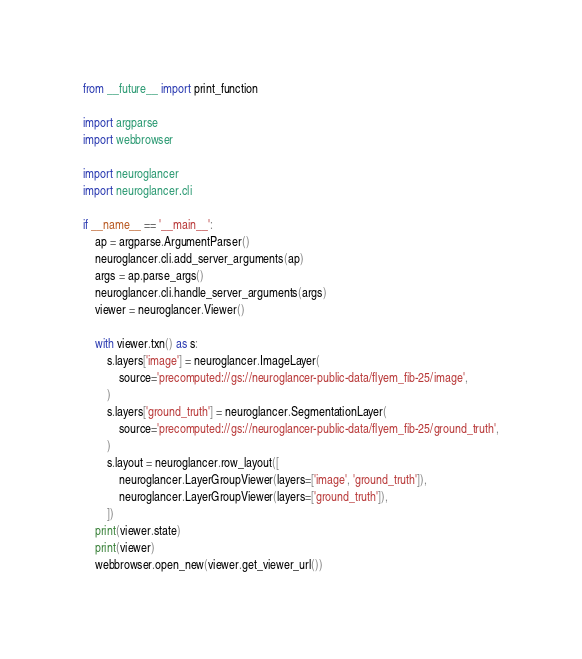Convert code to text. <code><loc_0><loc_0><loc_500><loc_500><_Python_>from __future__ import print_function

import argparse
import webbrowser

import neuroglancer
import neuroglancer.cli

if __name__ == '__main__':
    ap = argparse.ArgumentParser()
    neuroglancer.cli.add_server_arguments(ap)
    args = ap.parse_args()
    neuroglancer.cli.handle_server_arguments(args)
    viewer = neuroglancer.Viewer()

    with viewer.txn() as s:
        s.layers['image'] = neuroglancer.ImageLayer(
            source='precomputed://gs://neuroglancer-public-data/flyem_fib-25/image',
        )
        s.layers['ground_truth'] = neuroglancer.SegmentationLayer(
            source='precomputed://gs://neuroglancer-public-data/flyem_fib-25/ground_truth',
        )
        s.layout = neuroglancer.row_layout([
            neuroglancer.LayerGroupViewer(layers=['image', 'ground_truth']),
            neuroglancer.LayerGroupViewer(layers=['ground_truth']),
        ])
    print(viewer.state)
    print(viewer)
    webbrowser.open_new(viewer.get_viewer_url())
</code> 